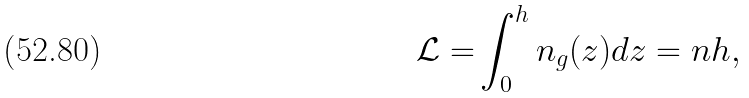Convert formula to latex. <formula><loc_0><loc_0><loc_500><loc_500>\mathcal { L = } \int _ { 0 } ^ { h } n _ { g } ( z ) d z = n h ,</formula> 